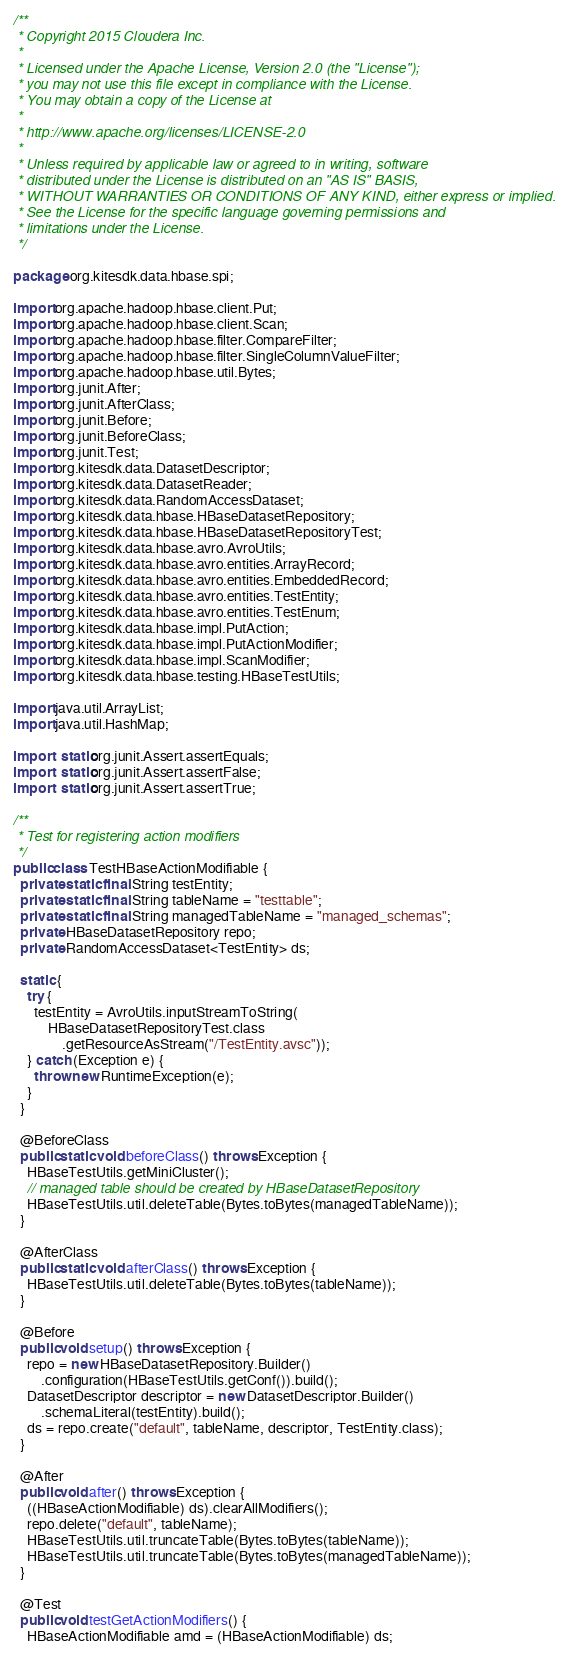<code> <loc_0><loc_0><loc_500><loc_500><_Java_>/**
 * Copyright 2015 Cloudera Inc.
 *
 * Licensed under the Apache License, Version 2.0 (the "License");
 * you may not use this file except in compliance with the License.
 * You may obtain a copy of the License at
 *
 * http://www.apache.org/licenses/LICENSE-2.0
 *
 * Unless required by applicable law or agreed to in writing, software
 * distributed under the License is distributed on an "AS IS" BASIS,
 * WITHOUT WARRANTIES OR CONDITIONS OF ANY KIND, either express or implied.
 * See the License for the specific language governing permissions and
 * limitations under the License.
 */

package org.kitesdk.data.hbase.spi;

import org.apache.hadoop.hbase.client.Put;
import org.apache.hadoop.hbase.client.Scan;
import org.apache.hadoop.hbase.filter.CompareFilter;
import org.apache.hadoop.hbase.filter.SingleColumnValueFilter;
import org.apache.hadoop.hbase.util.Bytes;
import org.junit.After;
import org.junit.AfterClass;
import org.junit.Before;
import org.junit.BeforeClass;
import org.junit.Test;
import org.kitesdk.data.DatasetDescriptor;
import org.kitesdk.data.DatasetReader;
import org.kitesdk.data.RandomAccessDataset;
import org.kitesdk.data.hbase.HBaseDatasetRepository;
import org.kitesdk.data.hbase.HBaseDatasetRepositoryTest;
import org.kitesdk.data.hbase.avro.AvroUtils;
import org.kitesdk.data.hbase.avro.entities.ArrayRecord;
import org.kitesdk.data.hbase.avro.entities.EmbeddedRecord;
import org.kitesdk.data.hbase.avro.entities.TestEntity;
import org.kitesdk.data.hbase.avro.entities.TestEnum;
import org.kitesdk.data.hbase.impl.PutAction;
import org.kitesdk.data.hbase.impl.PutActionModifier;
import org.kitesdk.data.hbase.impl.ScanModifier;
import org.kitesdk.data.hbase.testing.HBaseTestUtils;

import java.util.ArrayList;
import java.util.HashMap;

import static org.junit.Assert.assertEquals;
import static org.junit.Assert.assertFalse;
import static org.junit.Assert.assertTrue;

/**
 * Test for registering action modifiers
 */
public class TestHBaseActionModifiable {
  private static final String testEntity;
  private static final String tableName = "testtable";
  private static final String managedTableName = "managed_schemas";
  private HBaseDatasetRepository repo;
  private RandomAccessDataset<TestEntity> ds;

  static {
    try {
      testEntity = AvroUtils.inputStreamToString(
          HBaseDatasetRepositoryTest.class
              .getResourceAsStream("/TestEntity.avsc"));
    } catch (Exception e) {
      throw new RuntimeException(e);
    }
  }

  @BeforeClass
  public static void beforeClass() throws Exception {
    HBaseTestUtils.getMiniCluster();
    // managed table should be created by HBaseDatasetRepository
    HBaseTestUtils.util.deleteTable(Bytes.toBytes(managedTableName));
  }

  @AfterClass
  public static void afterClass() throws Exception {
    HBaseTestUtils.util.deleteTable(Bytes.toBytes(tableName));
  }

  @Before
  public void setup() throws Exception {
    repo = new HBaseDatasetRepository.Builder()
        .configuration(HBaseTestUtils.getConf()).build();
    DatasetDescriptor descriptor = new DatasetDescriptor.Builder()
        .schemaLiteral(testEntity).build();
    ds = repo.create("default", tableName, descriptor, TestEntity.class);
  }

  @After
  public void after() throws Exception {
    ((HBaseActionModifiable) ds).clearAllModifiers();
    repo.delete("default", tableName);
    HBaseTestUtils.util.truncateTable(Bytes.toBytes(tableName));
    HBaseTestUtils.util.truncateTable(Bytes.toBytes(managedTableName));
  }

  @Test
  public void testGetActionModifiers() {
    HBaseActionModifiable amd = (HBaseActionModifiable) ds;</code> 